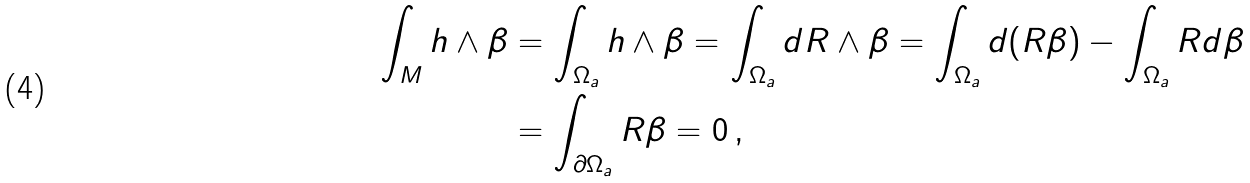Convert formula to latex. <formula><loc_0><loc_0><loc_500><loc_500>\int _ { M } h \wedge \beta & = \int _ { \Omega _ { a } } h \wedge \beta = \int _ { \Omega _ { a } } d R \wedge \beta = \int _ { \Omega _ { a } } d ( R \beta ) - \int _ { \Omega _ { a } } R d \beta \\ & = \int _ { \partial \Omega _ { a } } R \beta = 0 \, ,</formula> 